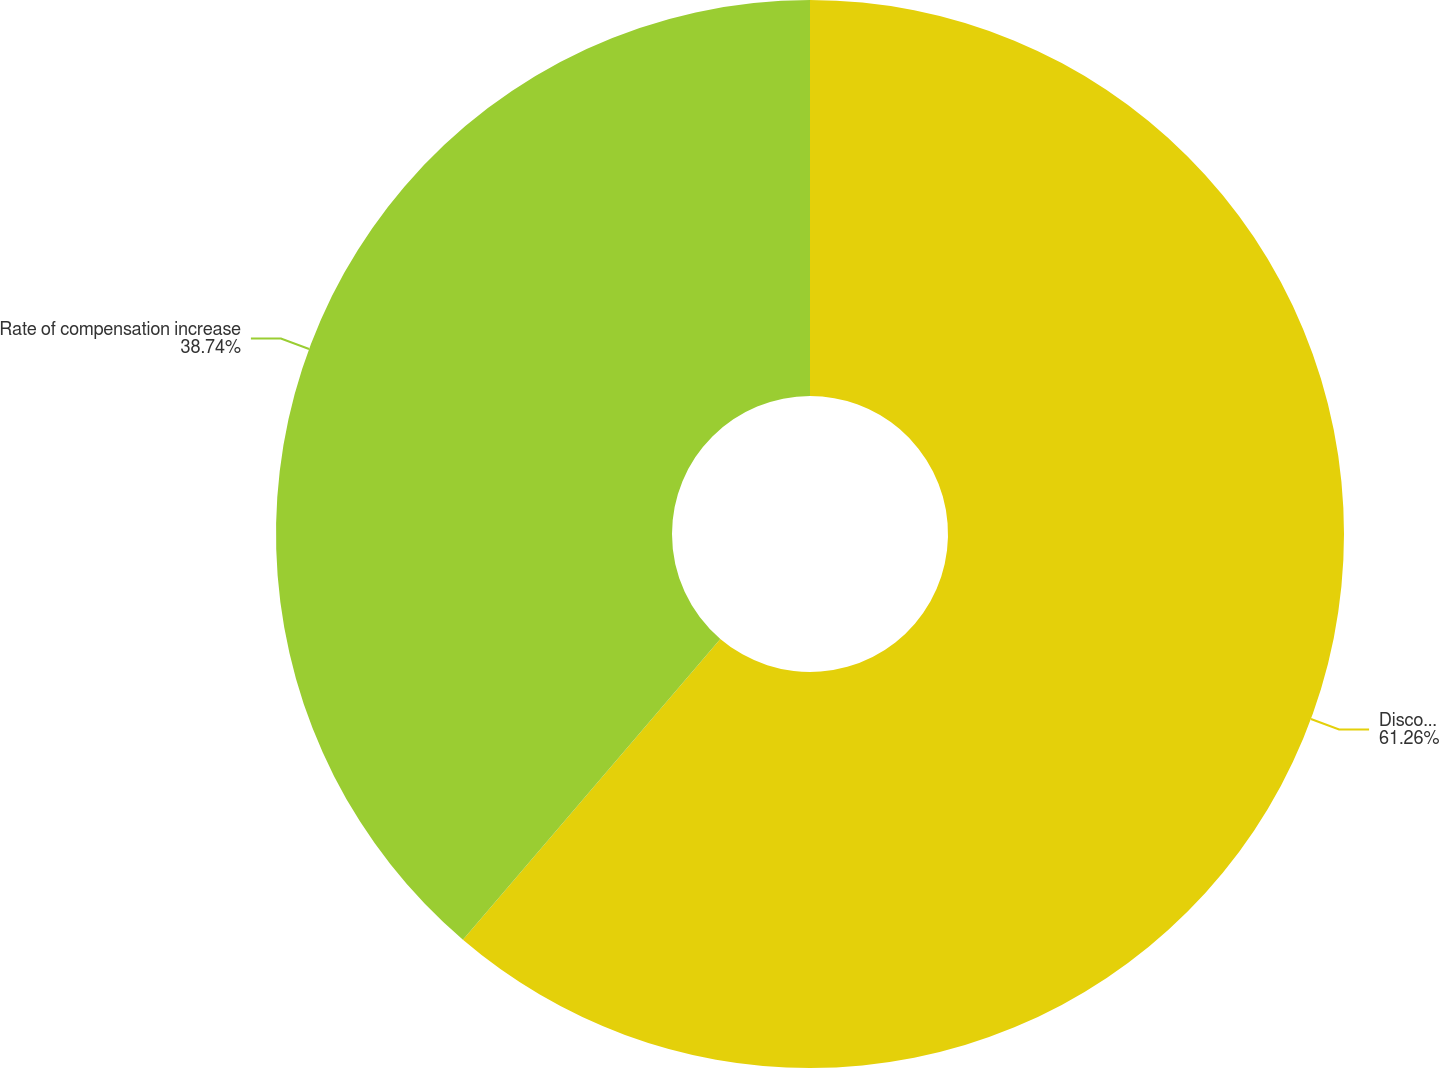Convert chart to OTSL. <chart><loc_0><loc_0><loc_500><loc_500><pie_chart><fcel>Discount rate<fcel>Rate of compensation increase<nl><fcel>61.26%<fcel>38.74%<nl></chart> 